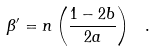<formula> <loc_0><loc_0><loc_500><loc_500>\beta ^ { \prime } = n \left ( \frac { 1 - 2 b } { 2 a } \right ) \ .</formula> 